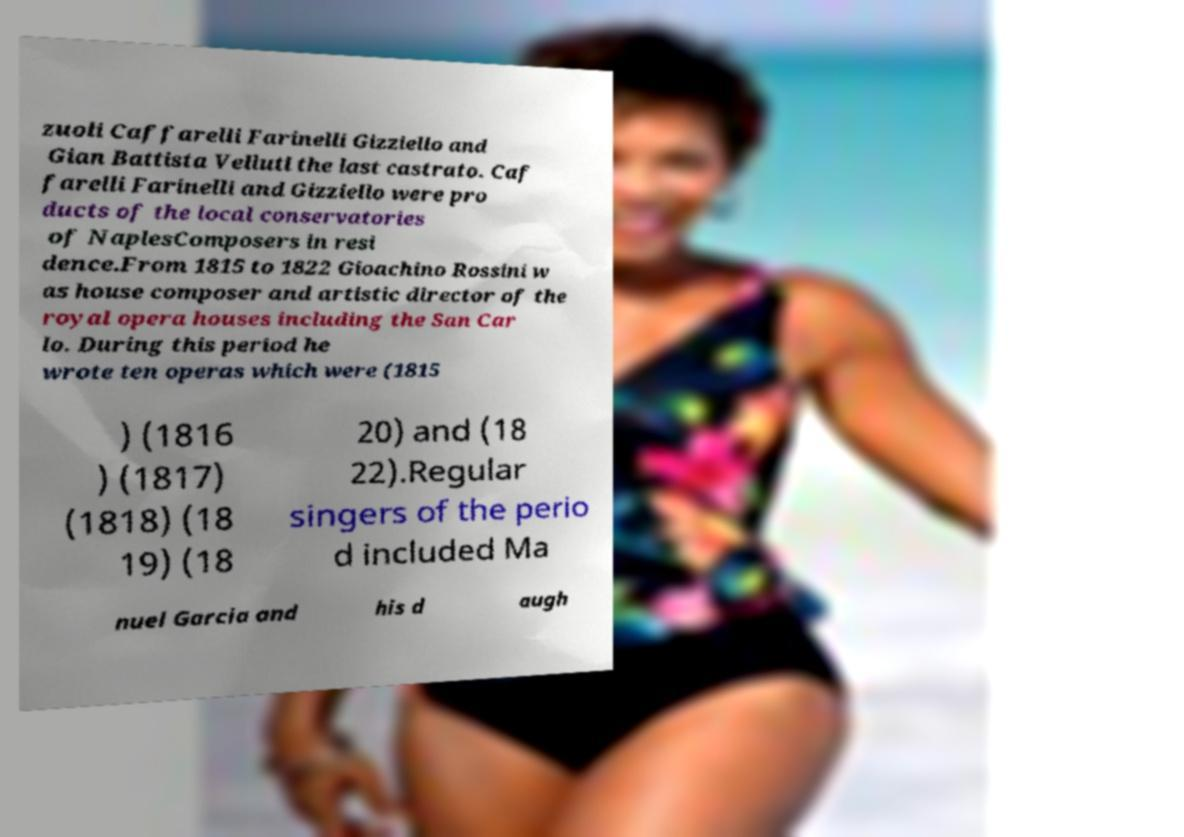What messages or text are displayed in this image? I need them in a readable, typed format. zuoli Caffarelli Farinelli Gizziello and Gian Battista Velluti the last castrato. Caf farelli Farinelli and Gizziello were pro ducts of the local conservatories of NaplesComposers in resi dence.From 1815 to 1822 Gioachino Rossini w as house composer and artistic director of the royal opera houses including the San Car lo. During this period he wrote ten operas which were (1815 ) (1816 ) (1817) (1818) (18 19) (18 20) and (18 22).Regular singers of the perio d included Ma nuel Garcia and his d augh 